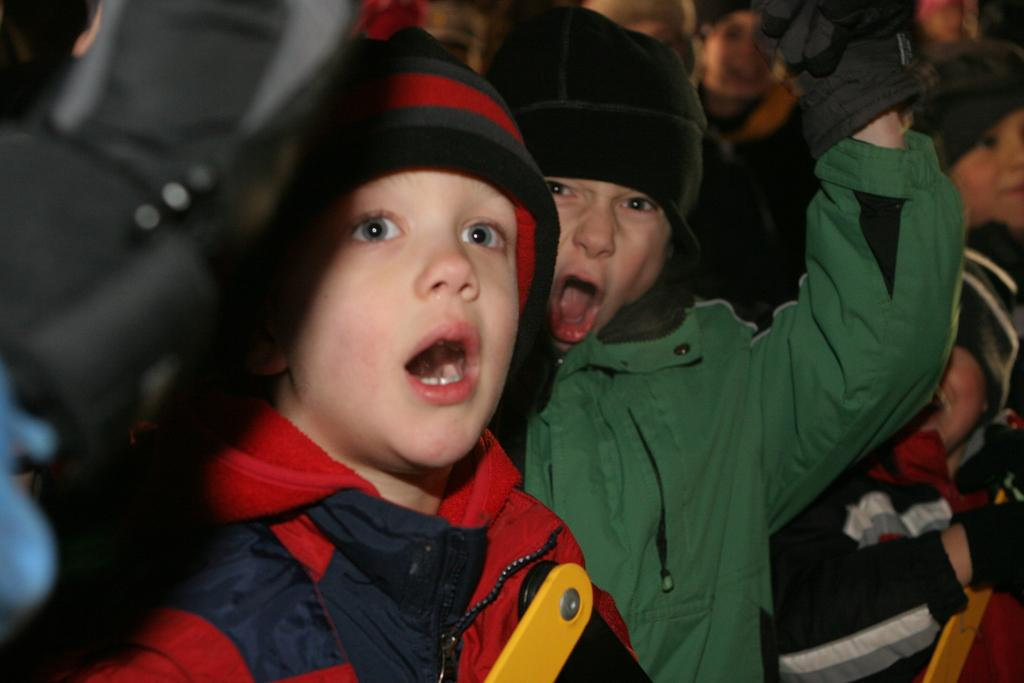Who is present in the image? There are kids in the image. What are the kids wearing on their heads? The kids are wearing caps. What type of dirt can be seen on the kids' shoes in the image? There is no dirt visible on the kids' shoes in the image. How does the breath of the kids affect the image? The breath of the kids does not affect the image, as it is a still image and not a video. 